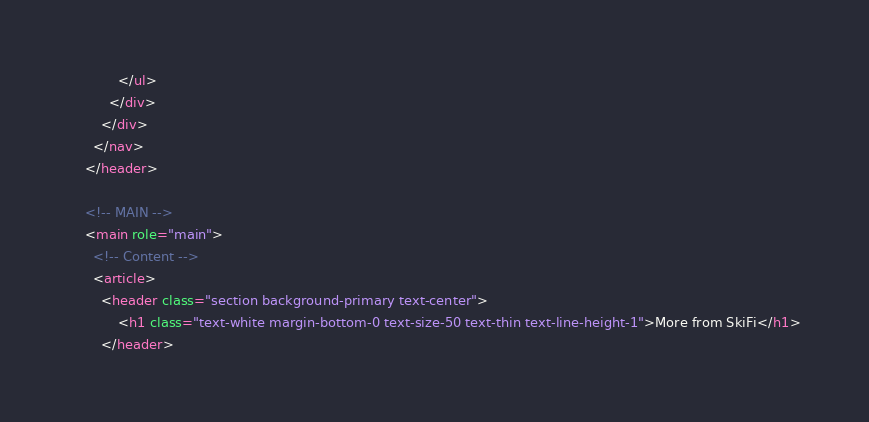Convert code to text. <code><loc_0><loc_0><loc_500><loc_500><_HTML_>            </ul>
          </div>
        </div>
      </nav>
    </header>
    
    <!-- MAIN -->
    <main role="main">
      <!-- Content -->
      <article>
        <header class="section background-primary text-center">
            <h1 class="text-white margin-bottom-0 text-size-50 text-thin text-line-height-1">More from SkiFi</h1>
        </header></code> 